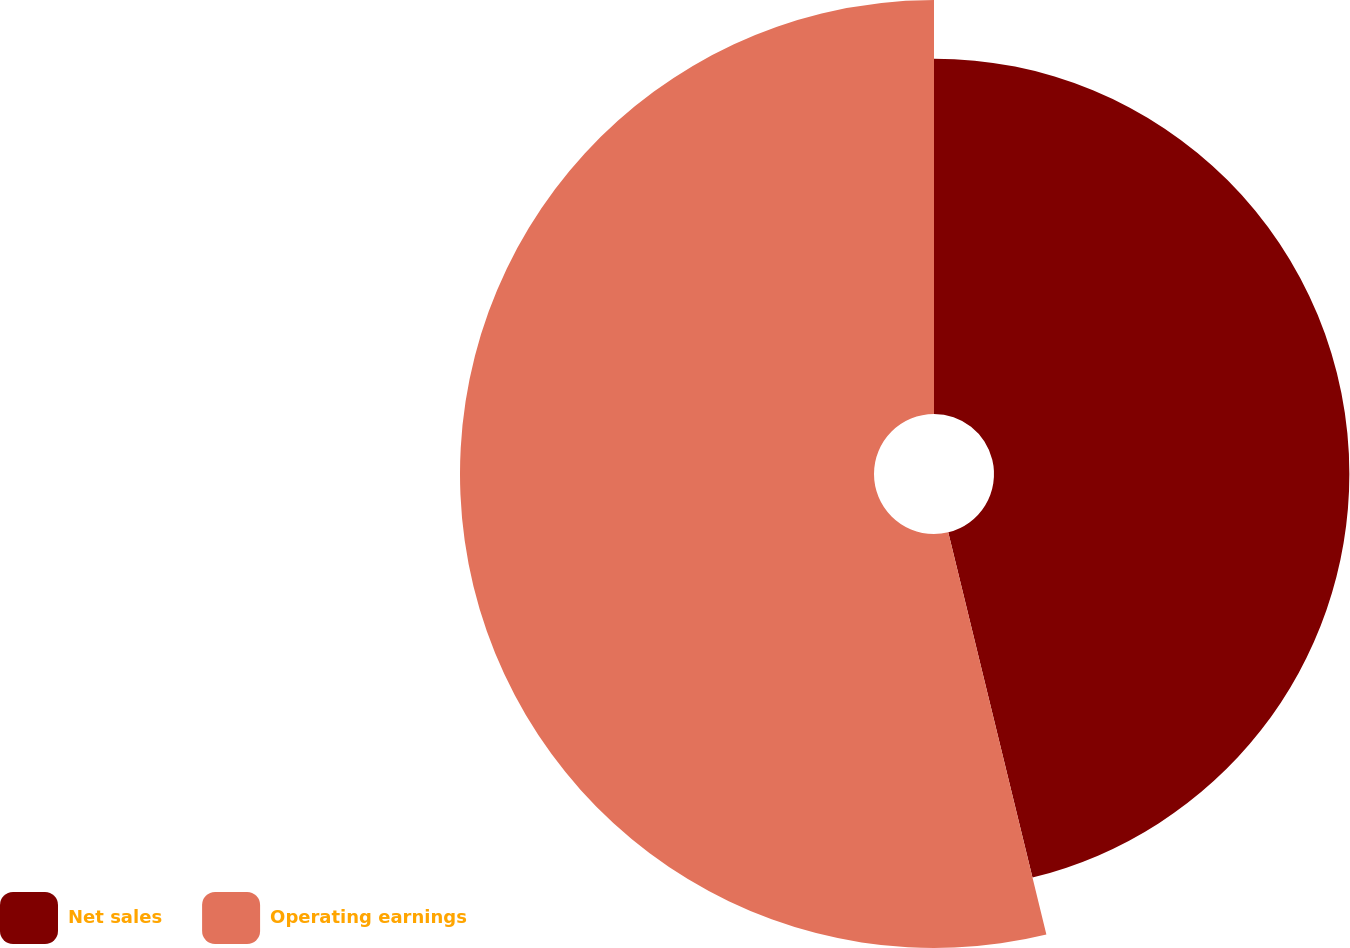Convert chart to OTSL. <chart><loc_0><loc_0><loc_500><loc_500><pie_chart><fcel>Net sales<fcel>Operating earnings<nl><fcel>46.19%<fcel>53.81%<nl></chart> 